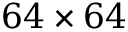Convert formula to latex. <formula><loc_0><loc_0><loc_500><loc_500>6 4 \times 6 4</formula> 